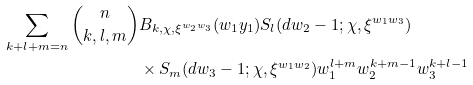Convert formula to latex. <formula><loc_0><loc_0><loc_500><loc_500>\sum _ { k + l + m = n } \binom { n } { k , l , m } & B _ { k , \chi , \xi ^ { w _ { 2 } w _ { 3 } } } ( w _ { 1 } y _ { 1 } ) S _ { l } ( d w _ { 2 } - 1 ; \chi , \xi ^ { w _ { 1 } w _ { 3 } } ) \\ & \times S _ { m } ( d w _ { 3 } - 1 ; \chi , \xi ^ { w _ { 1 } w _ { 2 } } ) w _ { 1 } ^ { l + m } w _ { 2 } ^ { k + m - 1 } w _ { 3 } ^ { k + l - 1 }</formula> 